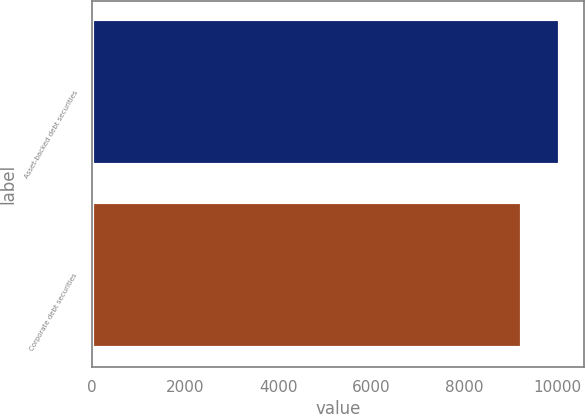<chart> <loc_0><loc_0><loc_500><loc_500><bar_chart><fcel>Asset-backed debt securities<fcel>Corporate debt securities<nl><fcel>10058<fcel>9245<nl></chart> 